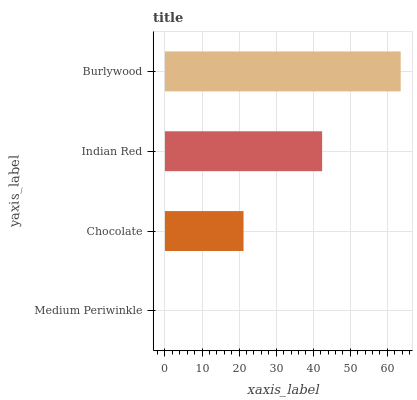Is Medium Periwinkle the minimum?
Answer yes or no. Yes. Is Burlywood the maximum?
Answer yes or no. Yes. Is Chocolate the minimum?
Answer yes or no. No. Is Chocolate the maximum?
Answer yes or no. No. Is Chocolate greater than Medium Periwinkle?
Answer yes or no. Yes. Is Medium Periwinkle less than Chocolate?
Answer yes or no. Yes. Is Medium Periwinkle greater than Chocolate?
Answer yes or no. No. Is Chocolate less than Medium Periwinkle?
Answer yes or no. No. Is Indian Red the high median?
Answer yes or no. Yes. Is Chocolate the low median?
Answer yes or no. Yes. Is Chocolate the high median?
Answer yes or no. No. Is Indian Red the low median?
Answer yes or no. No. 